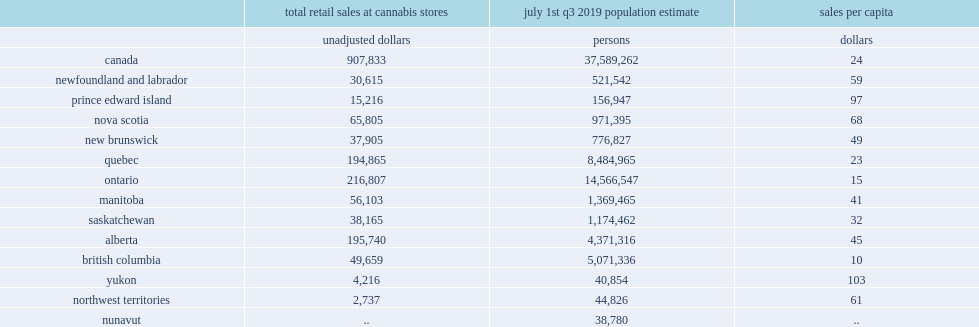Which province had the largest retail sales at cannabis stores? Ontario. Which province had the lowest sales per capita values in the country? British columbia. Which province had the highest sales per capita values in the country? Yukon. 